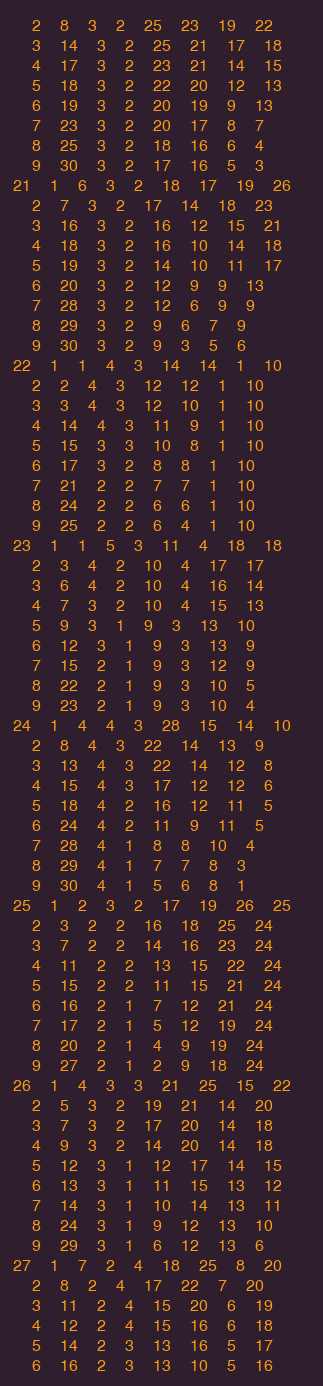<code> <loc_0><loc_0><loc_500><loc_500><_ObjectiveC_>	2	8	3	2	25	23	19	22	
	3	14	3	2	25	21	17	18	
	4	17	3	2	23	21	14	15	
	5	18	3	2	22	20	12	13	
	6	19	3	2	20	19	9	13	
	7	23	3	2	20	17	8	7	
	8	25	3	2	18	16	6	4	
	9	30	3	2	17	16	5	3	
21	1	6	3	2	18	17	19	26	
	2	7	3	2	17	14	18	23	
	3	16	3	2	16	12	15	21	
	4	18	3	2	16	10	14	18	
	5	19	3	2	14	10	11	17	
	6	20	3	2	12	9	9	13	
	7	28	3	2	12	6	9	9	
	8	29	3	2	9	6	7	9	
	9	30	3	2	9	3	5	6	
22	1	1	4	3	14	14	1	10	
	2	2	4	3	12	12	1	10	
	3	3	4	3	12	10	1	10	
	4	14	4	3	11	9	1	10	
	5	15	3	3	10	8	1	10	
	6	17	3	2	8	8	1	10	
	7	21	2	2	7	7	1	10	
	8	24	2	2	6	6	1	10	
	9	25	2	2	6	4	1	10	
23	1	1	5	3	11	4	18	18	
	2	3	4	2	10	4	17	17	
	3	6	4	2	10	4	16	14	
	4	7	3	2	10	4	15	13	
	5	9	3	1	9	3	13	10	
	6	12	3	1	9	3	13	9	
	7	15	2	1	9	3	12	9	
	8	22	2	1	9	3	10	5	
	9	23	2	1	9	3	10	4	
24	1	4	4	3	28	15	14	10	
	2	8	4	3	22	14	13	9	
	3	13	4	3	22	14	12	8	
	4	15	4	3	17	12	12	6	
	5	18	4	2	16	12	11	5	
	6	24	4	2	11	9	11	5	
	7	28	4	1	8	8	10	4	
	8	29	4	1	7	7	8	3	
	9	30	4	1	5	6	8	1	
25	1	2	3	2	17	19	26	25	
	2	3	2	2	16	18	25	24	
	3	7	2	2	14	16	23	24	
	4	11	2	2	13	15	22	24	
	5	15	2	2	11	15	21	24	
	6	16	2	1	7	12	21	24	
	7	17	2	1	5	12	19	24	
	8	20	2	1	4	9	19	24	
	9	27	2	1	2	9	18	24	
26	1	4	3	3	21	25	15	22	
	2	5	3	2	19	21	14	20	
	3	7	3	2	17	20	14	18	
	4	9	3	2	14	20	14	18	
	5	12	3	1	12	17	14	15	
	6	13	3	1	11	15	13	12	
	7	14	3	1	10	14	13	11	
	8	24	3	1	9	12	13	10	
	9	29	3	1	6	12	13	6	
27	1	7	2	4	18	25	8	20	
	2	8	2	4	17	22	7	20	
	3	11	2	4	15	20	6	19	
	4	12	2	4	15	16	6	18	
	5	14	2	3	13	16	5	17	
	6	16	2	3	13	10	5	16	</code> 